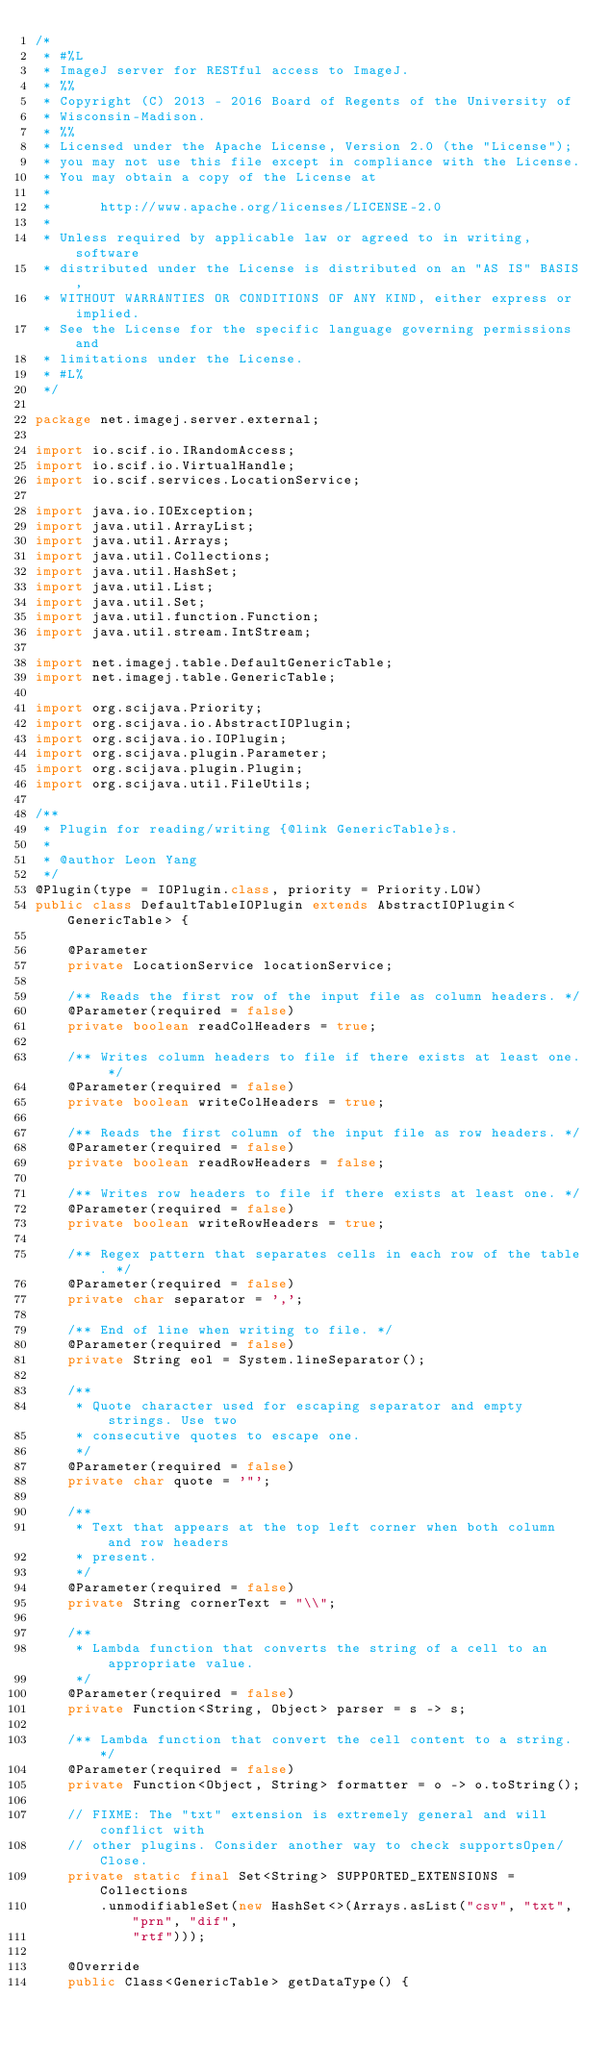<code> <loc_0><loc_0><loc_500><loc_500><_Java_>/*
 * #%L
 * ImageJ server for RESTful access to ImageJ.
 * %%
 * Copyright (C) 2013 - 2016 Board of Regents of the University of
 * Wisconsin-Madison.
 * %%
 * Licensed under the Apache License, Version 2.0 (the "License");
 * you may not use this file except in compliance with the License.
 * You may obtain a copy of the License at
 * 
 *      http://www.apache.org/licenses/LICENSE-2.0
 * 
 * Unless required by applicable law or agreed to in writing, software
 * distributed under the License is distributed on an "AS IS" BASIS,
 * WITHOUT WARRANTIES OR CONDITIONS OF ANY KIND, either express or implied.
 * See the License for the specific language governing permissions and
 * limitations under the License.
 * #L%
 */

package net.imagej.server.external;

import io.scif.io.IRandomAccess;
import io.scif.io.VirtualHandle;
import io.scif.services.LocationService;

import java.io.IOException;
import java.util.ArrayList;
import java.util.Arrays;
import java.util.Collections;
import java.util.HashSet;
import java.util.List;
import java.util.Set;
import java.util.function.Function;
import java.util.stream.IntStream;

import net.imagej.table.DefaultGenericTable;
import net.imagej.table.GenericTable;

import org.scijava.Priority;
import org.scijava.io.AbstractIOPlugin;
import org.scijava.io.IOPlugin;
import org.scijava.plugin.Parameter;
import org.scijava.plugin.Plugin;
import org.scijava.util.FileUtils;

/**
 * Plugin for reading/writing {@link GenericTable}s.
 * 
 * @author Leon Yang
 */
@Plugin(type = IOPlugin.class, priority = Priority.LOW)
public class DefaultTableIOPlugin extends AbstractIOPlugin<GenericTable> {

	@Parameter
	private LocationService locationService;

	/** Reads the first row of the input file as column headers. */
	@Parameter(required = false)
	private boolean readColHeaders = true;

	/** Writes column headers to file if there exists at least one. */
	@Parameter(required = false)
	private boolean writeColHeaders = true;

	/** Reads the first column of the input file as row headers. */
	@Parameter(required = false)
	private boolean readRowHeaders = false;

	/** Writes row headers to file if there exists at least one. */
	@Parameter(required = false)
	private boolean writeRowHeaders = true;

	/** Regex pattern that separates cells in each row of the table. */
	@Parameter(required = false)
	private char separator = ',';

	/** End of line when writing to file. */
	@Parameter(required = false)
	private String eol = System.lineSeparator();

	/**
	 * Quote character used for escaping separator and empty strings. Use two
	 * consecutive quotes to escape one.
	 */
	@Parameter(required = false)
	private char quote = '"';

	/**
	 * Text that appears at the top left corner when both column and row headers
	 * present.
	 */
	@Parameter(required = false)
	private String cornerText = "\\";

	/**
	 * Lambda function that converts the string of a cell to an appropriate value.
	 */
	@Parameter(required = false)
	private Function<String, Object> parser = s -> s;

	/** Lambda function that convert the cell content to a string. */
	@Parameter(required = false)
	private Function<Object, String> formatter = o -> o.toString();

	// FIXME: The "txt" extension is extremely general and will conflict with
	// other plugins. Consider another way to check supportsOpen/Close.
	private static final Set<String> SUPPORTED_EXTENSIONS = Collections
		.unmodifiableSet(new HashSet<>(Arrays.asList("csv", "txt", "prn", "dif",
			"rtf")));

	@Override
	public Class<GenericTable> getDataType() {</code> 